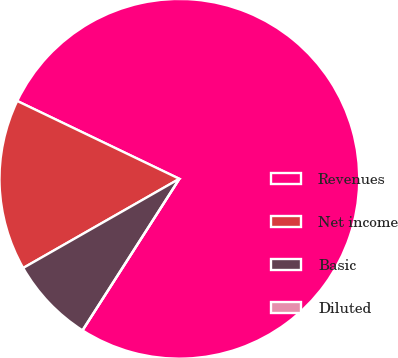Convert chart. <chart><loc_0><loc_0><loc_500><loc_500><pie_chart><fcel>Revenues<fcel>Net income<fcel>Basic<fcel>Diluted<nl><fcel>76.92%<fcel>15.38%<fcel>7.69%<fcel>0.0%<nl></chart> 